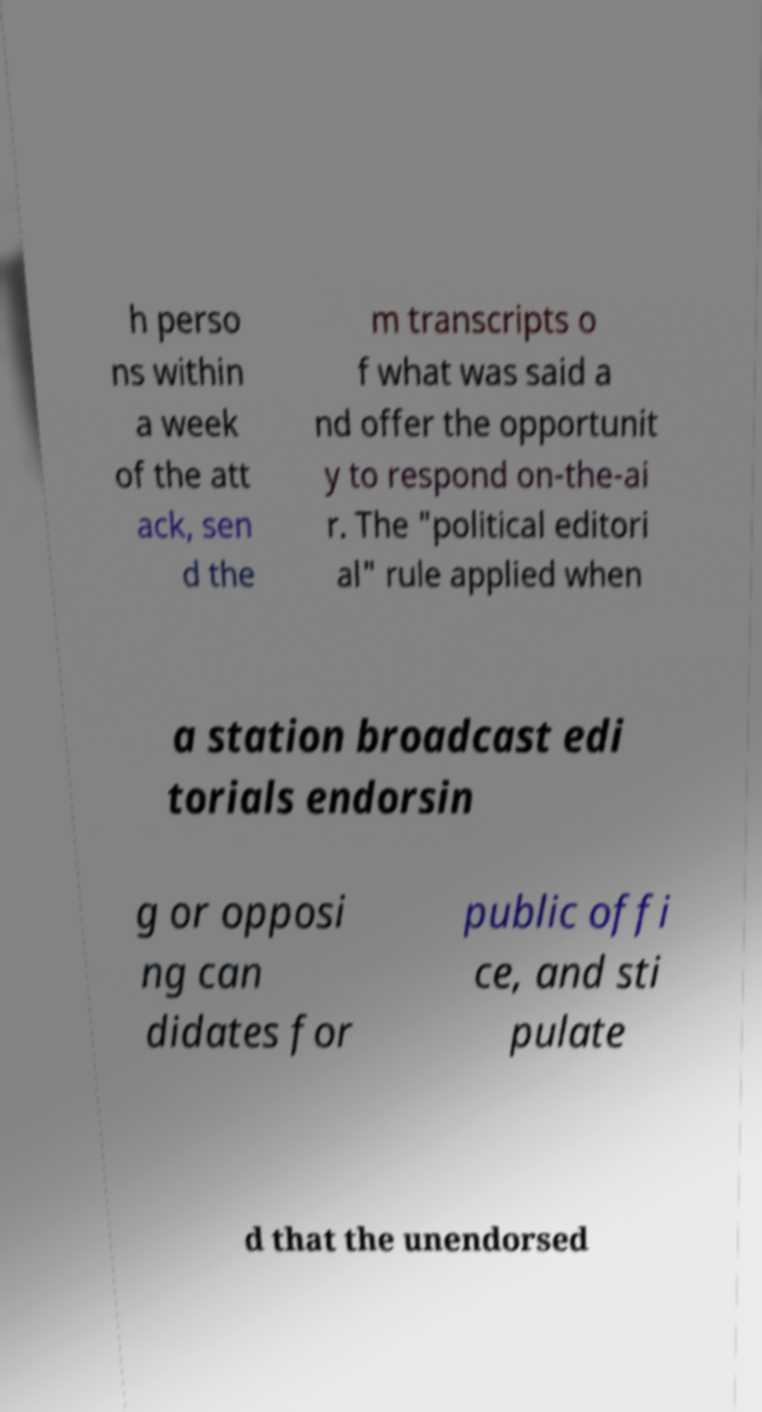I need the written content from this picture converted into text. Can you do that? h perso ns within a week of the att ack, sen d the m transcripts o f what was said a nd offer the opportunit y to respond on-the-ai r. The "political editori al" rule applied when a station broadcast edi torials endorsin g or opposi ng can didates for public offi ce, and sti pulate d that the unendorsed 